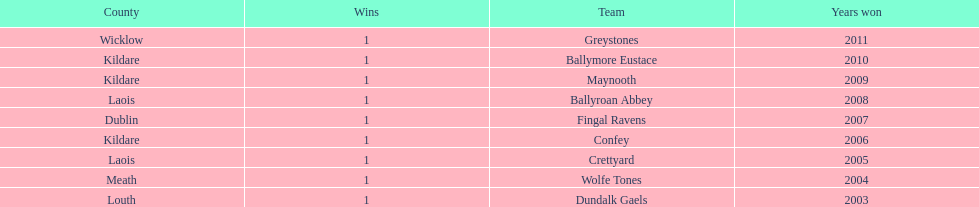Which team won previous to crettyard? Wolfe Tones. 